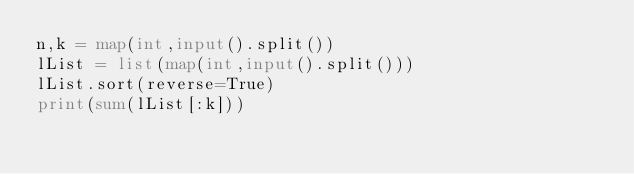<code> <loc_0><loc_0><loc_500><loc_500><_Python_>n,k = map(int,input().split())
lList = list(map(int,input().split()))
lList.sort(reverse=True)
print(sum(lList[:k]))</code> 